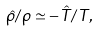<formula> <loc_0><loc_0><loc_500><loc_500>\hat { \rho } / \rho \simeq - \hat { T } / T ,</formula> 